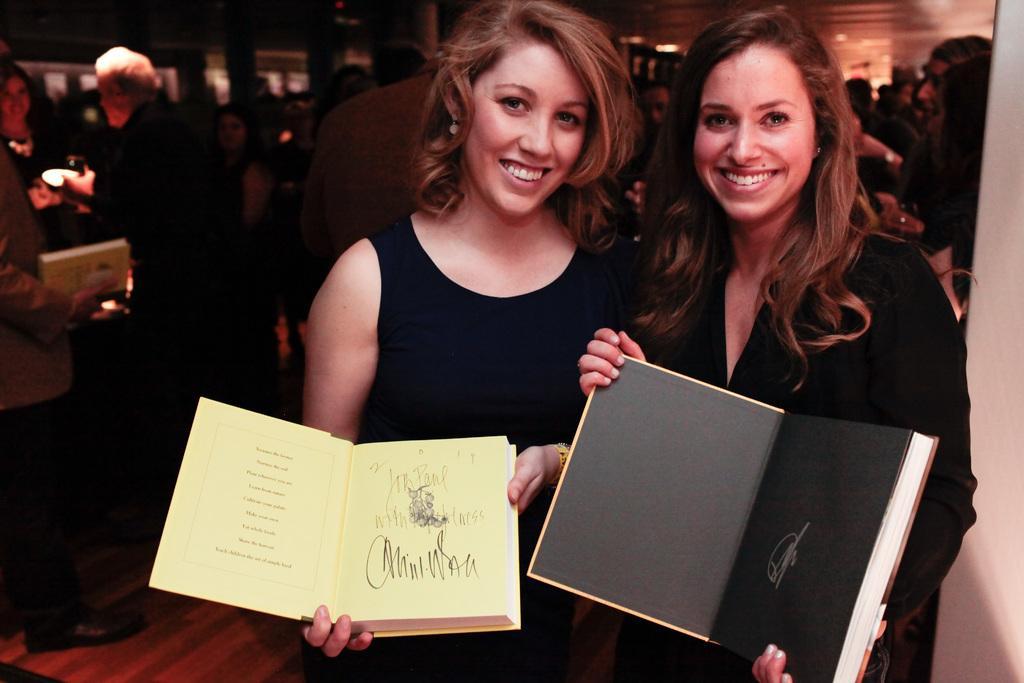Please provide a concise description of this image. In this image we can see two women smiling and holding the books and standing. In the background we can see the people. We can also see the ceiling and also the floor. On the left we can see the person holding the book and standing. 